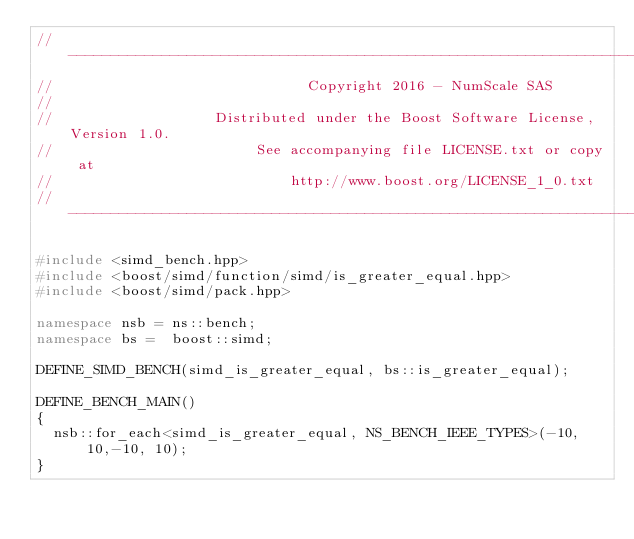Convert code to text. <code><loc_0><loc_0><loc_500><loc_500><_C++_>// -------------------------------------------------------------------------------------------------
//                              Copyright 2016 - NumScale SAS
//
//                   Distributed under the Boost Software License, Version 1.0.
//                        See accompanying file LICENSE.txt or copy at
//                            http://www.boost.org/LICENSE_1_0.txt
// -------------------------------------------------------------------------------------------------

#include <simd_bench.hpp>
#include <boost/simd/function/simd/is_greater_equal.hpp>
#include <boost/simd/pack.hpp>

namespace nsb = ns::bench;
namespace bs =  boost::simd;

DEFINE_SIMD_BENCH(simd_is_greater_equal, bs::is_greater_equal);

DEFINE_BENCH_MAIN()
{
  nsb::for_each<simd_is_greater_equal, NS_BENCH_IEEE_TYPES>(-10, 10,-10, 10);
}
</code> 